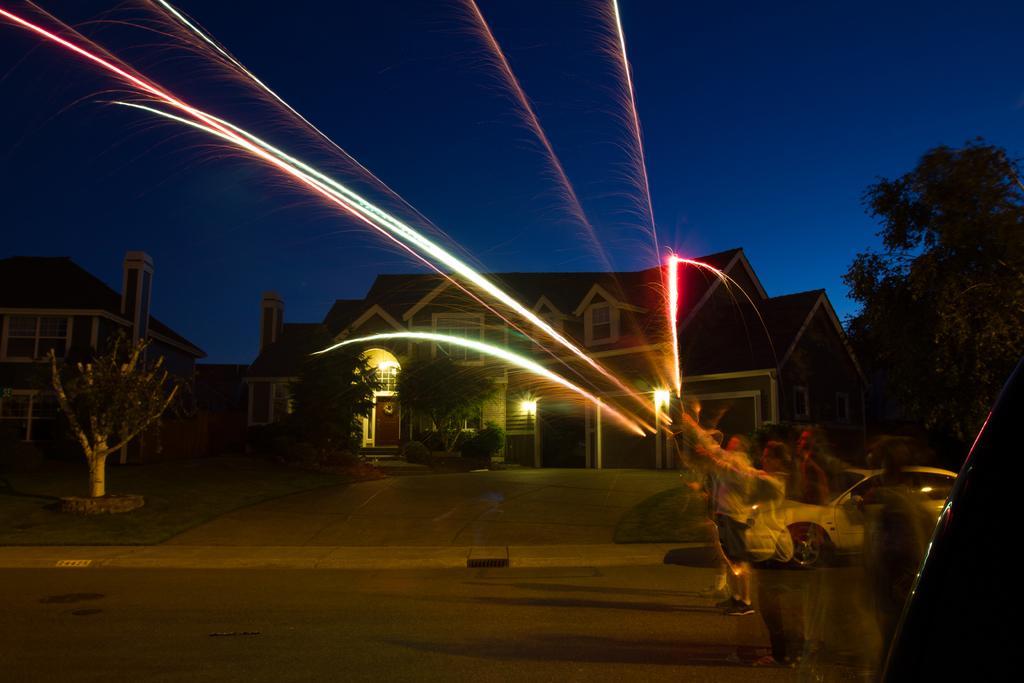Can you describe this image briefly? In this image we can see few people. Some are playing with fireworks. Also there is a car. In the background there are buildings with windows and there are trees. Also there is sky. And the image is looking blur on the left side. 